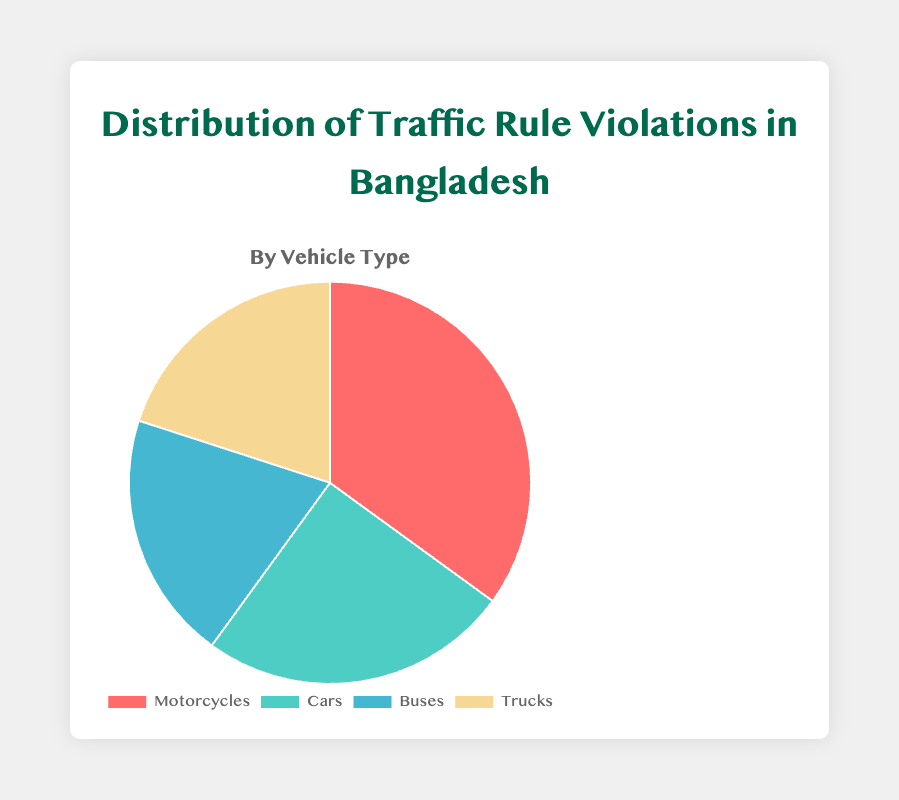Which vehicle type has the highest percentage of traffic rule violations? The figure shows that Motorcycles have the largest segment in the pie chart with 35%.
Answer: Motorcycles Which two vehicle types have an equal percentage of traffic rule violations? The figure indicates that Buses and Trucks each occupy an equal segment of the pie chart with 20%.
Answer: Buses and Trucks How much more is the percentage of traffic rule violations by Motorcycles compared to Cars? Motorcycles have a 35% share and Cars have a 25% share. The difference is 35% - 25% = 10%.
Answer: 10% What is the combined percentage of traffic rule violations by Cars and Buses? Cars account for 25% and Buses account for 20%. Their combined percentage is 25% + 20% = 45%.
Answer: 45% Which vehicle type contributes the least to traffic rule violations? Both Buses and Trucks contribute the least with a 20% share each, both are the smallest sections in the pie chart.
Answer: Buses and Trucks How does the percentage of traffic rule violations by Cars compare to the combined percentage of Buses and Trucks? Cars have 25%. The combined total for Buses and Trucks is 20% + 20% = 40%. 40% is greater than 25%.
Answer: Buses and Trucks are greater If traffic rule violations by Motorcycles were reduced by half, what would their new percentage be? The original percentage is 35%. Reducing it by half is 35% / 2 = 17.5%.
Answer: 17.5% What percentage of traffic rule violations do Trucks contribute to? The pie chart shows that Trucks contribute 20%.
Answer: 20% Arrange the vehicle types in descending order of their traffic rule violation percentages. From the pie chart, the order from highest to lowest percentage is Motorcycles (35%), Cars (25%), Buses (20%), and Trucks (20%).
Answer: Motorcycles, Cars, Buses, Trucks 